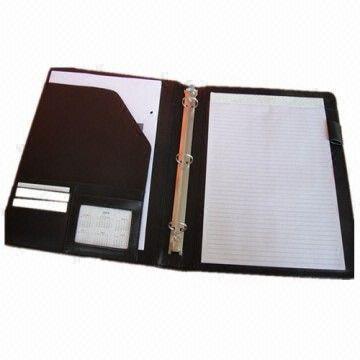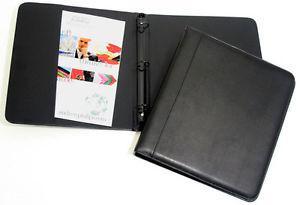The first image is the image on the left, the second image is the image on the right. For the images displayed, is the sentence "One image shows a leather notebook both opened and closed, while the second image shows one or more notebooks, but only one opened." factually correct? Answer yes or no. Yes. The first image is the image on the left, the second image is the image on the right. Assess this claim about the two images: "Left image shows an open binder with paper in it.". Correct or not? Answer yes or no. Yes. 